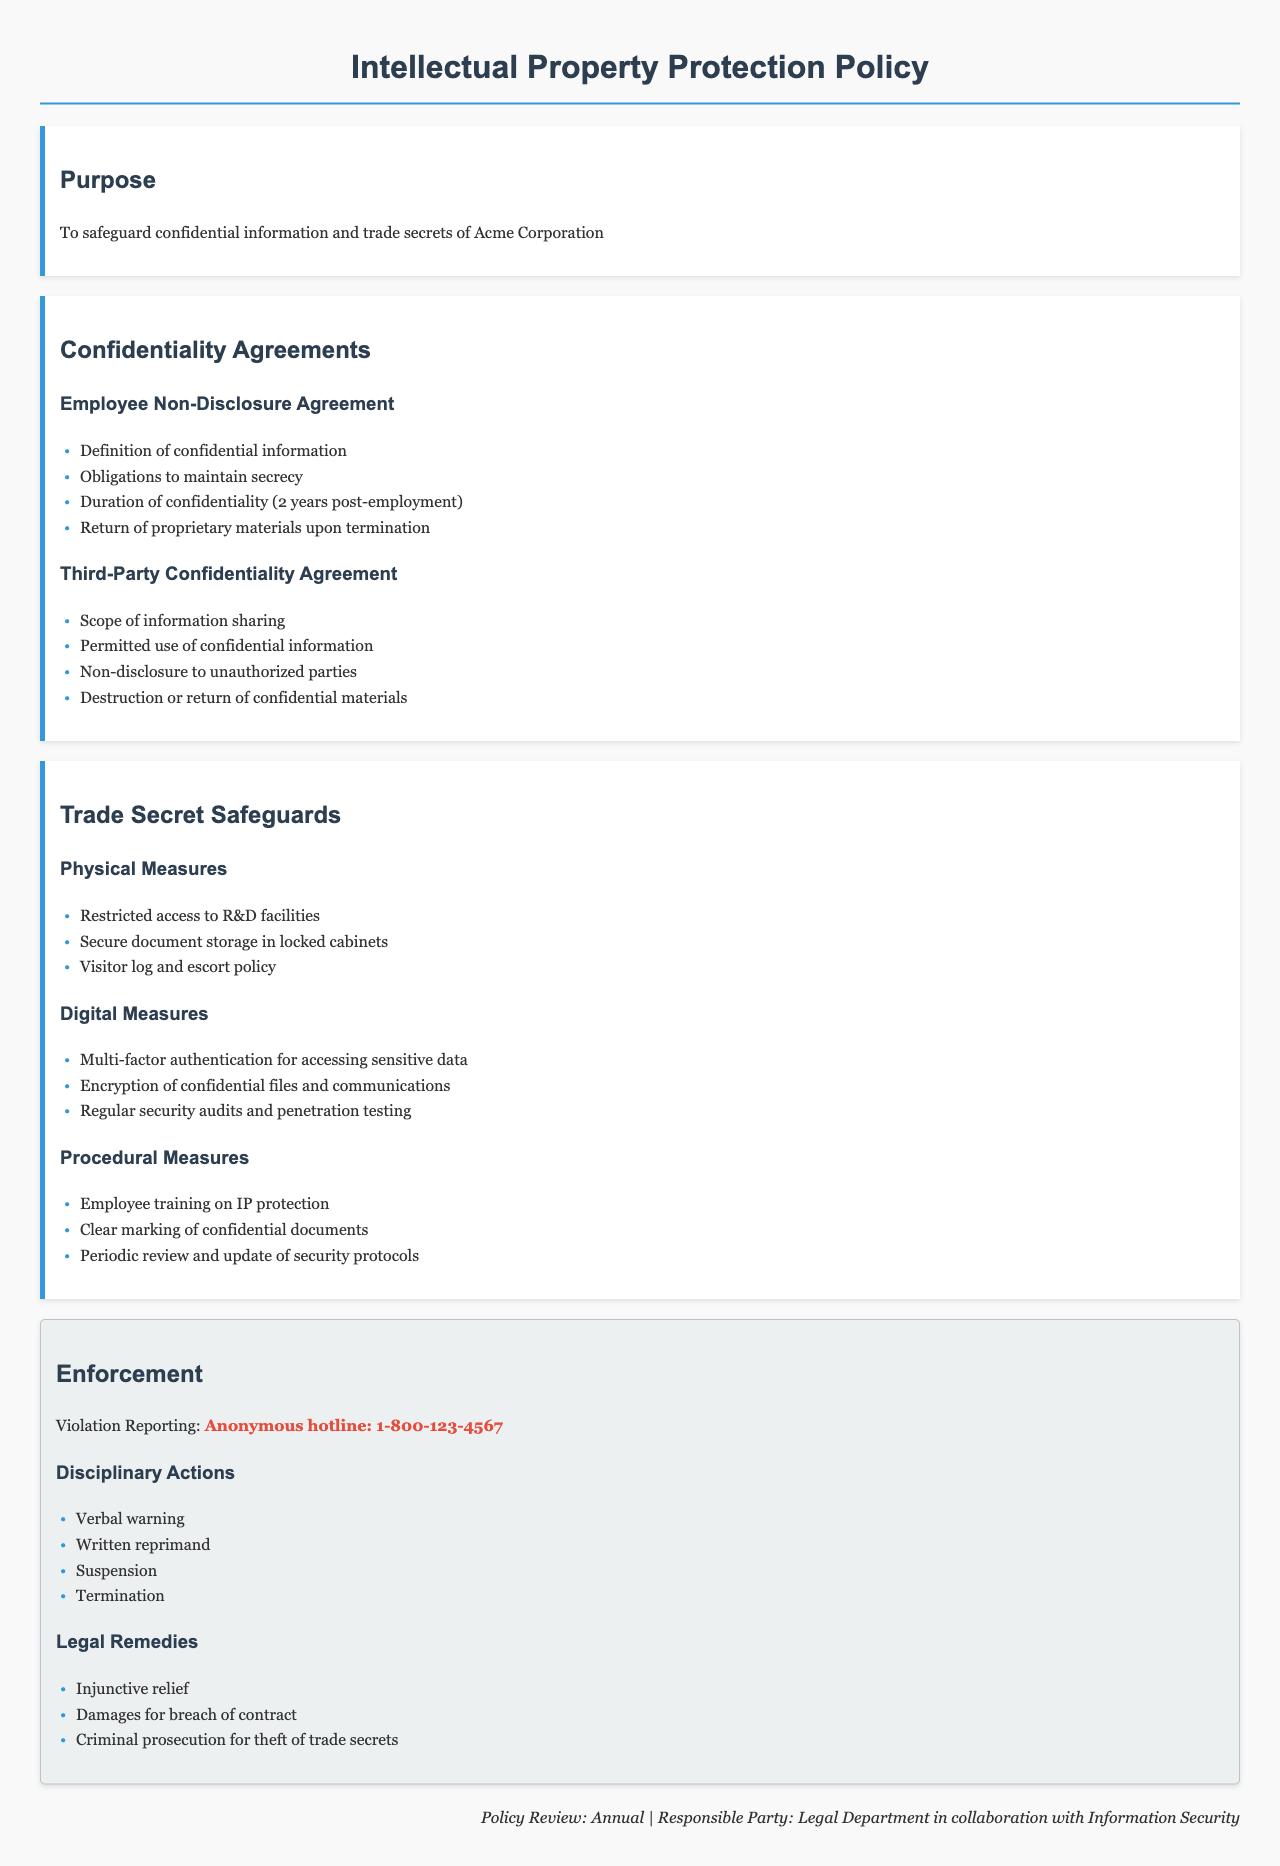what is the duration of confidentiality after employment? The document specifies the duration of confidentiality as 2 years post-employment.
Answer: 2 years who is responsible for the annual policy review? The policy states that the responsible party for the annual review is the Legal Department in collaboration with Information Security.
Answer: Legal Department what should employees do with proprietary materials upon termination? The document states that employees must return proprietary materials upon termination.
Answer: Return what is a physical measure for safeguarding trade secrets? One of the physical measures mentioned is restricted access to R&D facilities.
Answer: Restricted access what hotline is provided for violation reporting? The document provides an anonymous hotline number for reporting violations.
Answer: 1-800-123-4567 what is one type of disciplinary action mentioned for violations? Among the disciplinary actions listed, a verbal warning is mentioned as one option.
Answer: Verbal warning how often should security protocols be reviewed and updated? The document indicates that security protocols should be periodically reviewed and updated.
Answer: Periodically what type of authentication is required for accessing sensitive data? The document states that multi-factor authentication is required for accessing sensitive data.
Answer: Multi-factor authentication what type of legal remedy can be pursued for breach of contract? The document mentions damages for breach of contract as one legal remedy that can be pursued.
Answer: Damages for breach of contract 